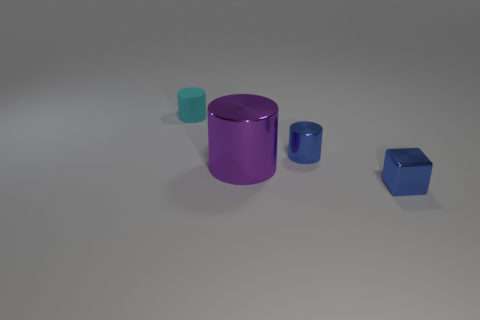Add 4 big green objects. How many objects exist? 8 Subtract all cylinders. How many objects are left? 1 Add 1 matte cylinders. How many matte cylinders are left? 2 Add 3 big metallic cylinders. How many big metallic cylinders exist? 4 Subtract 0 cyan blocks. How many objects are left? 4 Subtract all cyan metallic blocks. Subtract all small matte cylinders. How many objects are left? 3 